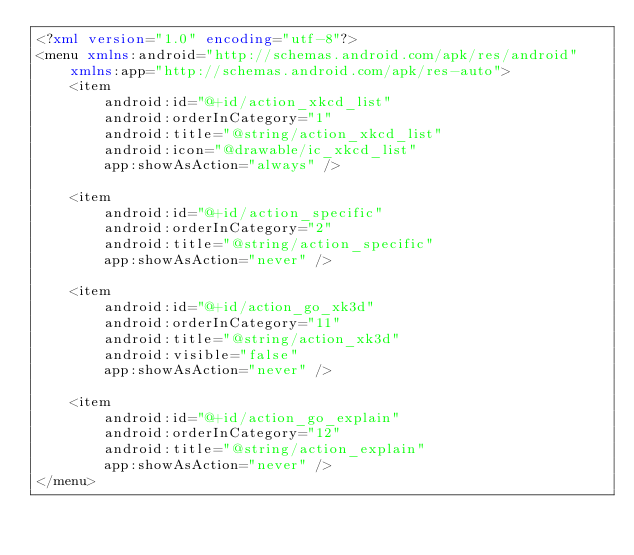<code> <loc_0><loc_0><loc_500><loc_500><_XML_><?xml version="1.0" encoding="utf-8"?>
<menu xmlns:android="http://schemas.android.com/apk/res/android"
    xmlns:app="http://schemas.android.com/apk/res-auto">
    <item
        android:id="@+id/action_xkcd_list"
        android:orderInCategory="1"
        android:title="@string/action_xkcd_list"
        android:icon="@drawable/ic_xkcd_list"
        app:showAsAction="always" />

    <item
        android:id="@+id/action_specific"
        android:orderInCategory="2"
        android:title="@string/action_specific"
        app:showAsAction="never" />

    <item
        android:id="@+id/action_go_xk3d"
        android:orderInCategory="11"
        android:title="@string/action_xk3d"
        android:visible="false"
        app:showAsAction="never" />

    <item
        android:id="@+id/action_go_explain"
        android:orderInCategory="12"
        android:title="@string/action_explain"
        app:showAsAction="never" />
</menu></code> 